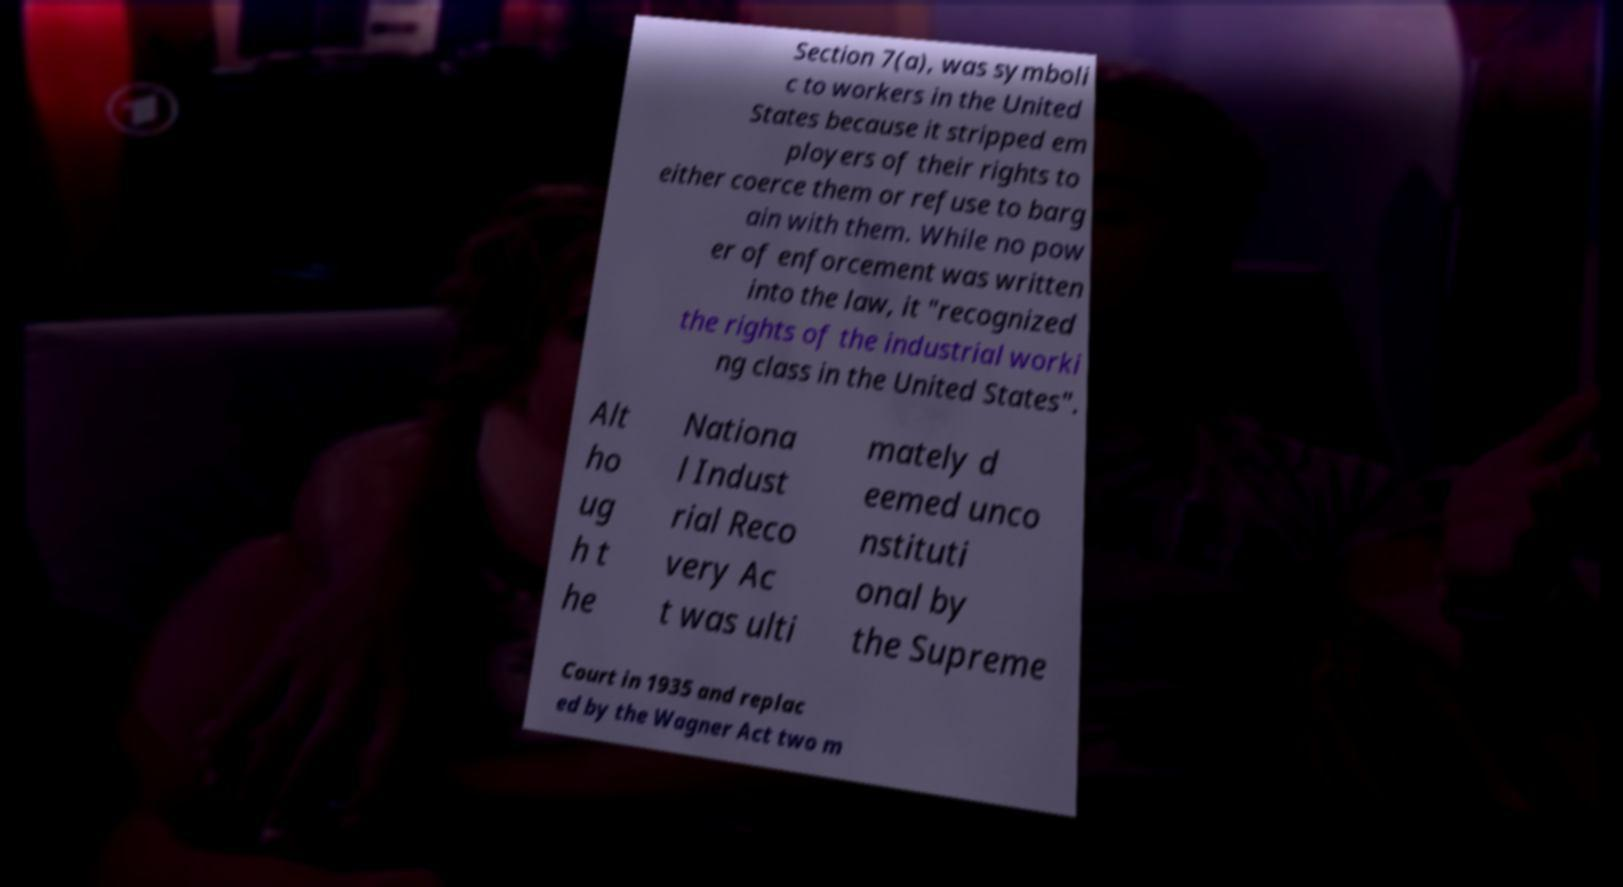What messages or text are displayed in this image? I need them in a readable, typed format. Section 7(a), was symboli c to workers in the United States because it stripped em ployers of their rights to either coerce them or refuse to barg ain with them. While no pow er of enforcement was written into the law, it "recognized the rights of the industrial worki ng class in the United States". Alt ho ug h t he Nationa l Indust rial Reco very Ac t was ulti mately d eemed unco nstituti onal by the Supreme Court in 1935 and replac ed by the Wagner Act two m 